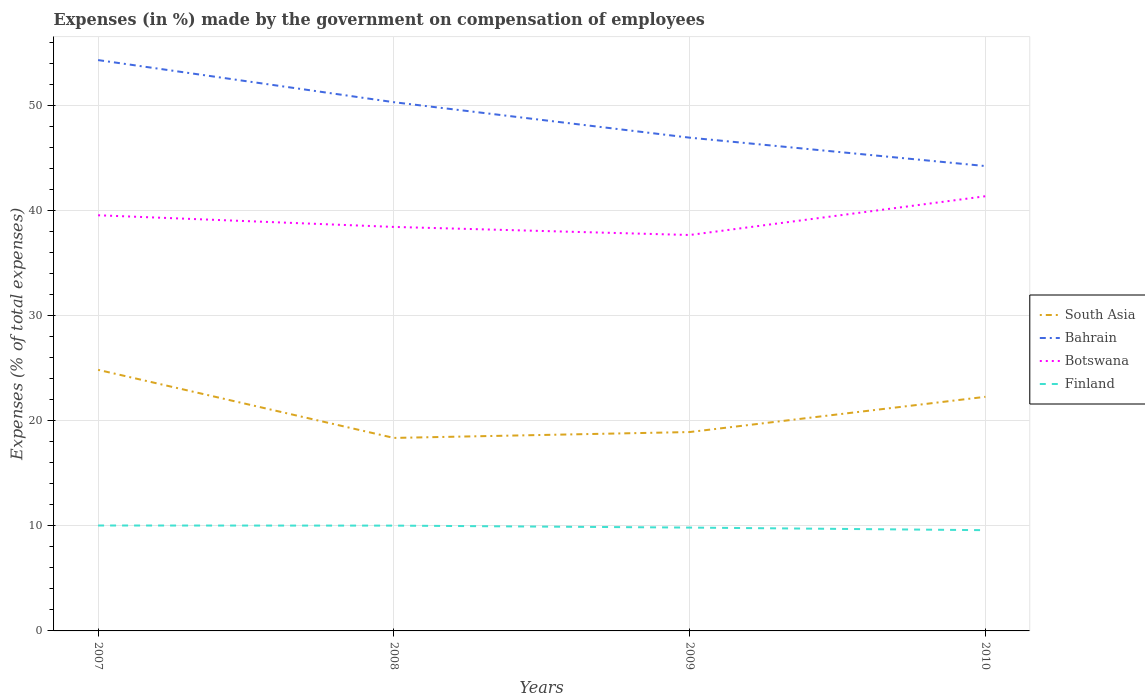How many different coloured lines are there?
Offer a very short reply. 4. Does the line corresponding to Botswana intersect with the line corresponding to South Asia?
Your answer should be compact. No. Is the number of lines equal to the number of legend labels?
Provide a short and direct response. Yes. Across all years, what is the maximum percentage of expenses made by the government on compensation of employees in Finland?
Provide a succinct answer. 9.58. What is the total percentage of expenses made by the government on compensation of employees in Bahrain in the graph?
Give a very brief answer. 6.07. What is the difference between the highest and the second highest percentage of expenses made by the government on compensation of employees in Finland?
Keep it short and to the point. 0.45. What is the difference between the highest and the lowest percentage of expenses made by the government on compensation of employees in South Asia?
Your answer should be compact. 2. How many lines are there?
Offer a very short reply. 4. How many years are there in the graph?
Provide a short and direct response. 4. Are the values on the major ticks of Y-axis written in scientific E-notation?
Provide a succinct answer. No. Does the graph contain any zero values?
Give a very brief answer. No. Does the graph contain grids?
Give a very brief answer. Yes. Where does the legend appear in the graph?
Offer a very short reply. Center right. How many legend labels are there?
Provide a succinct answer. 4. What is the title of the graph?
Provide a short and direct response. Expenses (in %) made by the government on compensation of employees. Does "Tunisia" appear as one of the legend labels in the graph?
Offer a terse response. No. What is the label or title of the Y-axis?
Give a very brief answer. Expenses (% of total expenses). What is the Expenses (% of total expenses) in South Asia in 2007?
Your response must be concise. 24.84. What is the Expenses (% of total expenses) of Bahrain in 2007?
Give a very brief answer. 54.31. What is the Expenses (% of total expenses) in Botswana in 2007?
Offer a very short reply. 39.54. What is the Expenses (% of total expenses) of Finland in 2007?
Give a very brief answer. 10.03. What is the Expenses (% of total expenses) in South Asia in 2008?
Your response must be concise. 18.36. What is the Expenses (% of total expenses) of Bahrain in 2008?
Your response must be concise. 50.3. What is the Expenses (% of total expenses) in Botswana in 2008?
Your response must be concise. 38.43. What is the Expenses (% of total expenses) of Finland in 2008?
Keep it short and to the point. 10.02. What is the Expenses (% of total expenses) of South Asia in 2009?
Your answer should be very brief. 18.92. What is the Expenses (% of total expenses) of Bahrain in 2009?
Keep it short and to the point. 46.93. What is the Expenses (% of total expenses) of Botswana in 2009?
Offer a terse response. 37.66. What is the Expenses (% of total expenses) in Finland in 2009?
Your answer should be compact. 9.83. What is the Expenses (% of total expenses) of South Asia in 2010?
Provide a short and direct response. 22.27. What is the Expenses (% of total expenses) in Bahrain in 2010?
Offer a terse response. 44.22. What is the Expenses (% of total expenses) in Botswana in 2010?
Offer a terse response. 41.35. What is the Expenses (% of total expenses) in Finland in 2010?
Keep it short and to the point. 9.58. Across all years, what is the maximum Expenses (% of total expenses) of South Asia?
Provide a short and direct response. 24.84. Across all years, what is the maximum Expenses (% of total expenses) in Bahrain?
Offer a very short reply. 54.31. Across all years, what is the maximum Expenses (% of total expenses) of Botswana?
Your answer should be compact. 41.35. Across all years, what is the maximum Expenses (% of total expenses) in Finland?
Provide a succinct answer. 10.03. Across all years, what is the minimum Expenses (% of total expenses) of South Asia?
Your answer should be very brief. 18.36. Across all years, what is the minimum Expenses (% of total expenses) in Bahrain?
Make the answer very short. 44.22. Across all years, what is the minimum Expenses (% of total expenses) in Botswana?
Ensure brevity in your answer.  37.66. Across all years, what is the minimum Expenses (% of total expenses) in Finland?
Ensure brevity in your answer.  9.58. What is the total Expenses (% of total expenses) in South Asia in the graph?
Your response must be concise. 84.39. What is the total Expenses (% of total expenses) in Bahrain in the graph?
Offer a very short reply. 195.75. What is the total Expenses (% of total expenses) of Botswana in the graph?
Keep it short and to the point. 156.99. What is the total Expenses (% of total expenses) of Finland in the graph?
Provide a succinct answer. 39.46. What is the difference between the Expenses (% of total expenses) of South Asia in 2007 and that in 2008?
Make the answer very short. 6.48. What is the difference between the Expenses (% of total expenses) in Bahrain in 2007 and that in 2008?
Keep it short and to the point. 4.01. What is the difference between the Expenses (% of total expenses) in Botswana in 2007 and that in 2008?
Offer a terse response. 1.11. What is the difference between the Expenses (% of total expenses) of Finland in 2007 and that in 2008?
Ensure brevity in your answer.  0.01. What is the difference between the Expenses (% of total expenses) in South Asia in 2007 and that in 2009?
Provide a succinct answer. 5.92. What is the difference between the Expenses (% of total expenses) of Bahrain in 2007 and that in 2009?
Provide a succinct answer. 7.38. What is the difference between the Expenses (% of total expenses) of Botswana in 2007 and that in 2009?
Offer a very short reply. 1.88. What is the difference between the Expenses (% of total expenses) of Finland in 2007 and that in 2009?
Offer a very short reply. 0.2. What is the difference between the Expenses (% of total expenses) of South Asia in 2007 and that in 2010?
Your response must be concise. 2.57. What is the difference between the Expenses (% of total expenses) of Bahrain in 2007 and that in 2010?
Provide a short and direct response. 10.08. What is the difference between the Expenses (% of total expenses) in Botswana in 2007 and that in 2010?
Your response must be concise. -1.81. What is the difference between the Expenses (% of total expenses) of Finland in 2007 and that in 2010?
Offer a terse response. 0.45. What is the difference between the Expenses (% of total expenses) of South Asia in 2008 and that in 2009?
Keep it short and to the point. -0.56. What is the difference between the Expenses (% of total expenses) in Bahrain in 2008 and that in 2009?
Offer a terse response. 3.37. What is the difference between the Expenses (% of total expenses) in Botswana in 2008 and that in 2009?
Your answer should be very brief. 0.77. What is the difference between the Expenses (% of total expenses) in Finland in 2008 and that in 2009?
Give a very brief answer. 0.19. What is the difference between the Expenses (% of total expenses) in South Asia in 2008 and that in 2010?
Give a very brief answer. -3.91. What is the difference between the Expenses (% of total expenses) in Bahrain in 2008 and that in 2010?
Provide a succinct answer. 6.08. What is the difference between the Expenses (% of total expenses) in Botswana in 2008 and that in 2010?
Provide a short and direct response. -2.92. What is the difference between the Expenses (% of total expenses) in Finland in 2008 and that in 2010?
Your response must be concise. 0.43. What is the difference between the Expenses (% of total expenses) of South Asia in 2009 and that in 2010?
Offer a terse response. -3.35. What is the difference between the Expenses (% of total expenses) in Bahrain in 2009 and that in 2010?
Keep it short and to the point. 2.7. What is the difference between the Expenses (% of total expenses) in Botswana in 2009 and that in 2010?
Ensure brevity in your answer.  -3.69. What is the difference between the Expenses (% of total expenses) of Finland in 2009 and that in 2010?
Offer a terse response. 0.25. What is the difference between the Expenses (% of total expenses) of South Asia in 2007 and the Expenses (% of total expenses) of Bahrain in 2008?
Provide a succinct answer. -25.46. What is the difference between the Expenses (% of total expenses) in South Asia in 2007 and the Expenses (% of total expenses) in Botswana in 2008?
Offer a terse response. -13.6. What is the difference between the Expenses (% of total expenses) of South Asia in 2007 and the Expenses (% of total expenses) of Finland in 2008?
Your answer should be compact. 14.82. What is the difference between the Expenses (% of total expenses) of Bahrain in 2007 and the Expenses (% of total expenses) of Botswana in 2008?
Your answer should be very brief. 15.87. What is the difference between the Expenses (% of total expenses) in Bahrain in 2007 and the Expenses (% of total expenses) in Finland in 2008?
Offer a very short reply. 44.29. What is the difference between the Expenses (% of total expenses) of Botswana in 2007 and the Expenses (% of total expenses) of Finland in 2008?
Your answer should be compact. 29.52. What is the difference between the Expenses (% of total expenses) in South Asia in 2007 and the Expenses (% of total expenses) in Bahrain in 2009?
Offer a terse response. -22.09. What is the difference between the Expenses (% of total expenses) in South Asia in 2007 and the Expenses (% of total expenses) in Botswana in 2009?
Ensure brevity in your answer.  -12.83. What is the difference between the Expenses (% of total expenses) in South Asia in 2007 and the Expenses (% of total expenses) in Finland in 2009?
Offer a very short reply. 15.01. What is the difference between the Expenses (% of total expenses) in Bahrain in 2007 and the Expenses (% of total expenses) in Botswana in 2009?
Provide a short and direct response. 16.64. What is the difference between the Expenses (% of total expenses) of Bahrain in 2007 and the Expenses (% of total expenses) of Finland in 2009?
Your answer should be compact. 44.47. What is the difference between the Expenses (% of total expenses) of Botswana in 2007 and the Expenses (% of total expenses) of Finland in 2009?
Provide a succinct answer. 29.71. What is the difference between the Expenses (% of total expenses) in South Asia in 2007 and the Expenses (% of total expenses) in Bahrain in 2010?
Ensure brevity in your answer.  -19.39. What is the difference between the Expenses (% of total expenses) of South Asia in 2007 and the Expenses (% of total expenses) of Botswana in 2010?
Make the answer very short. -16.51. What is the difference between the Expenses (% of total expenses) of South Asia in 2007 and the Expenses (% of total expenses) of Finland in 2010?
Ensure brevity in your answer.  15.25. What is the difference between the Expenses (% of total expenses) in Bahrain in 2007 and the Expenses (% of total expenses) in Botswana in 2010?
Offer a terse response. 12.95. What is the difference between the Expenses (% of total expenses) of Bahrain in 2007 and the Expenses (% of total expenses) of Finland in 2010?
Provide a succinct answer. 44.72. What is the difference between the Expenses (% of total expenses) of Botswana in 2007 and the Expenses (% of total expenses) of Finland in 2010?
Provide a short and direct response. 29.96. What is the difference between the Expenses (% of total expenses) of South Asia in 2008 and the Expenses (% of total expenses) of Bahrain in 2009?
Offer a terse response. -28.56. What is the difference between the Expenses (% of total expenses) of South Asia in 2008 and the Expenses (% of total expenses) of Botswana in 2009?
Give a very brief answer. -19.3. What is the difference between the Expenses (% of total expenses) of South Asia in 2008 and the Expenses (% of total expenses) of Finland in 2009?
Your answer should be very brief. 8.53. What is the difference between the Expenses (% of total expenses) in Bahrain in 2008 and the Expenses (% of total expenses) in Botswana in 2009?
Provide a short and direct response. 12.63. What is the difference between the Expenses (% of total expenses) of Bahrain in 2008 and the Expenses (% of total expenses) of Finland in 2009?
Provide a succinct answer. 40.47. What is the difference between the Expenses (% of total expenses) in Botswana in 2008 and the Expenses (% of total expenses) in Finland in 2009?
Make the answer very short. 28.6. What is the difference between the Expenses (% of total expenses) of South Asia in 2008 and the Expenses (% of total expenses) of Bahrain in 2010?
Offer a terse response. -25.86. What is the difference between the Expenses (% of total expenses) in South Asia in 2008 and the Expenses (% of total expenses) in Botswana in 2010?
Give a very brief answer. -22.99. What is the difference between the Expenses (% of total expenses) in South Asia in 2008 and the Expenses (% of total expenses) in Finland in 2010?
Your answer should be compact. 8.78. What is the difference between the Expenses (% of total expenses) of Bahrain in 2008 and the Expenses (% of total expenses) of Botswana in 2010?
Make the answer very short. 8.95. What is the difference between the Expenses (% of total expenses) of Bahrain in 2008 and the Expenses (% of total expenses) of Finland in 2010?
Keep it short and to the point. 40.72. What is the difference between the Expenses (% of total expenses) in Botswana in 2008 and the Expenses (% of total expenses) in Finland in 2010?
Your answer should be compact. 28.85. What is the difference between the Expenses (% of total expenses) of South Asia in 2009 and the Expenses (% of total expenses) of Bahrain in 2010?
Provide a short and direct response. -25.3. What is the difference between the Expenses (% of total expenses) in South Asia in 2009 and the Expenses (% of total expenses) in Botswana in 2010?
Offer a very short reply. -22.43. What is the difference between the Expenses (% of total expenses) in South Asia in 2009 and the Expenses (% of total expenses) in Finland in 2010?
Keep it short and to the point. 9.34. What is the difference between the Expenses (% of total expenses) in Bahrain in 2009 and the Expenses (% of total expenses) in Botswana in 2010?
Provide a succinct answer. 5.57. What is the difference between the Expenses (% of total expenses) in Bahrain in 2009 and the Expenses (% of total expenses) in Finland in 2010?
Make the answer very short. 37.34. What is the difference between the Expenses (% of total expenses) of Botswana in 2009 and the Expenses (% of total expenses) of Finland in 2010?
Make the answer very short. 28.08. What is the average Expenses (% of total expenses) in South Asia per year?
Your answer should be compact. 21.1. What is the average Expenses (% of total expenses) of Bahrain per year?
Your answer should be compact. 48.94. What is the average Expenses (% of total expenses) in Botswana per year?
Keep it short and to the point. 39.25. What is the average Expenses (% of total expenses) in Finland per year?
Make the answer very short. 9.87. In the year 2007, what is the difference between the Expenses (% of total expenses) in South Asia and Expenses (% of total expenses) in Bahrain?
Ensure brevity in your answer.  -29.47. In the year 2007, what is the difference between the Expenses (% of total expenses) in South Asia and Expenses (% of total expenses) in Botswana?
Your answer should be very brief. -14.7. In the year 2007, what is the difference between the Expenses (% of total expenses) of South Asia and Expenses (% of total expenses) of Finland?
Your answer should be very brief. 14.81. In the year 2007, what is the difference between the Expenses (% of total expenses) in Bahrain and Expenses (% of total expenses) in Botswana?
Your response must be concise. 14.76. In the year 2007, what is the difference between the Expenses (% of total expenses) in Bahrain and Expenses (% of total expenses) in Finland?
Offer a terse response. 44.28. In the year 2007, what is the difference between the Expenses (% of total expenses) of Botswana and Expenses (% of total expenses) of Finland?
Provide a short and direct response. 29.51. In the year 2008, what is the difference between the Expenses (% of total expenses) in South Asia and Expenses (% of total expenses) in Bahrain?
Your response must be concise. -31.94. In the year 2008, what is the difference between the Expenses (% of total expenses) in South Asia and Expenses (% of total expenses) in Botswana?
Ensure brevity in your answer.  -20.07. In the year 2008, what is the difference between the Expenses (% of total expenses) of South Asia and Expenses (% of total expenses) of Finland?
Give a very brief answer. 8.34. In the year 2008, what is the difference between the Expenses (% of total expenses) of Bahrain and Expenses (% of total expenses) of Botswana?
Make the answer very short. 11.87. In the year 2008, what is the difference between the Expenses (% of total expenses) of Bahrain and Expenses (% of total expenses) of Finland?
Your response must be concise. 40.28. In the year 2008, what is the difference between the Expenses (% of total expenses) of Botswana and Expenses (% of total expenses) of Finland?
Your answer should be very brief. 28.42. In the year 2009, what is the difference between the Expenses (% of total expenses) in South Asia and Expenses (% of total expenses) in Bahrain?
Offer a terse response. -28.01. In the year 2009, what is the difference between the Expenses (% of total expenses) in South Asia and Expenses (% of total expenses) in Botswana?
Give a very brief answer. -18.75. In the year 2009, what is the difference between the Expenses (% of total expenses) in South Asia and Expenses (% of total expenses) in Finland?
Provide a succinct answer. 9.09. In the year 2009, what is the difference between the Expenses (% of total expenses) in Bahrain and Expenses (% of total expenses) in Botswana?
Provide a succinct answer. 9.26. In the year 2009, what is the difference between the Expenses (% of total expenses) of Bahrain and Expenses (% of total expenses) of Finland?
Your response must be concise. 37.09. In the year 2009, what is the difference between the Expenses (% of total expenses) of Botswana and Expenses (% of total expenses) of Finland?
Your answer should be very brief. 27.83. In the year 2010, what is the difference between the Expenses (% of total expenses) in South Asia and Expenses (% of total expenses) in Bahrain?
Provide a succinct answer. -21.95. In the year 2010, what is the difference between the Expenses (% of total expenses) in South Asia and Expenses (% of total expenses) in Botswana?
Your response must be concise. -19.08. In the year 2010, what is the difference between the Expenses (% of total expenses) in South Asia and Expenses (% of total expenses) in Finland?
Offer a terse response. 12.69. In the year 2010, what is the difference between the Expenses (% of total expenses) in Bahrain and Expenses (% of total expenses) in Botswana?
Keep it short and to the point. 2.87. In the year 2010, what is the difference between the Expenses (% of total expenses) of Bahrain and Expenses (% of total expenses) of Finland?
Your response must be concise. 34.64. In the year 2010, what is the difference between the Expenses (% of total expenses) in Botswana and Expenses (% of total expenses) in Finland?
Offer a terse response. 31.77. What is the ratio of the Expenses (% of total expenses) in South Asia in 2007 to that in 2008?
Offer a very short reply. 1.35. What is the ratio of the Expenses (% of total expenses) in Bahrain in 2007 to that in 2008?
Give a very brief answer. 1.08. What is the ratio of the Expenses (% of total expenses) of Botswana in 2007 to that in 2008?
Your answer should be compact. 1.03. What is the ratio of the Expenses (% of total expenses) of Finland in 2007 to that in 2008?
Keep it short and to the point. 1. What is the ratio of the Expenses (% of total expenses) in South Asia in 2007 to that in 2009?
Provide a succinct answer. 1.31. What is the ratio of the Expenses (% of total expenses) of Bahrain in 2007 to that in 2009?
Provide a short and direct response. 1.16. What is the ratio of the Expenses (% of total expenses) of Botswana in 2007 to that in 2009?
Provide a short and direct response. 1.05. What is the ratio of the Expenses (% of total expenses) in Finland in 2007 to that in 2009?
Your answer should be compact. 1.02. What is the ratio of the Expenses (% of total expenses) of South Asia in 2007 to that in 2010?
Give a very brief answer. 1.12. What is the ratio of the Expenses (% of total expenses) in Bahrain in 2007 to that in 2010?
Ensure brevity in your answer.  1.23. What is the ratio of the Expenses (% of total expenses) in Botswana in 2007 to that in 2010?
Give a very brief answer. 0.96. What is the ratio of the Expenses (% of total expenses) in Finland in 2007 to that in 2010?
Your response must be concise. 1.05. What is the ratio of the Expenses (% of total expenses) in South Asia in 2008 to that in 2009?
Offer a very short reply. 0.97. What is the ratio of the Expenses (% of total expenses) of Bahrain in 2008 to that in 2009?
Offer a terse response. 1.07. What is the ratio of the Expenses (% of total expenses) of Botswana in 2008 to that in 2009?
Offer a very short reply. 1.02. What is the ratio of the Expenses (% of total expenses) of Finland in 2008 to that in 2009?
Your response must be concise. 1.02. What is the ratio of the Expenses (% of total expenses) of South Asia in 2008 to that in 2010?
Offer a very short reply. 0.82. What is the ratio of the Expenses (% of total expenses) in Bahrain in 2008 to that in 2010?
Offer a very short reply. 1.14. What is the ratio of the Expenses (% of total expenses) in Botswana in 2008 to that in 2010?
Your response must be concise. 0.93. What is the ratio of the Expenses (% of total expenses) of Finland in 2008 to that in 2010?
Offer a terse response. 1.05. What is the ratio of the Expenses (% of total expenses) of South Asia in 2009 to that in 2010?
Your answer should be very brief. 0.85. What is the ratio of the Expenses (% of total expenses) of Bahrain in 2009 to that in 2010?
Offer a very short reply. 1.06. What is the ratio of the Expenses (% of total expenses) in Botswana in 2009 to that in 2010?
Provide a succinct answer. 0.91. What is the ratio of the Expenses (% of total expenses) of Finland in 2009 to that in 2010?
Give a very brief answer. 1.03. What is the difference between the highest and the second highest Expenses (% of total expenses) of South Asia?
Your answer should be very brief. 2.57. What is the difference between the highest and the second highest Expenses (% of total expenses) in Bahrain?
Provide a succinct answer. 4.01. What is the difference between the highest and the second highest Expenses (% of total expenses) of Botswana?
Provide a short and direct response. 1.81. What is the difference between the highest and the second highest Expenses (% of total expenses) in Finland?
Your answer should be compact. 0.01. What is the difference between the highest and the lowest Expenses (% of total expenses) in South Asia?
Offer a very short reply. 6.48. What is the difference between the highest and the lowest Expenses (% of total expenses) in Bahrain?
Offer a very short reply. 10.08. What is the difference between the highest and the lowest Expenses (% of total expenses) of Botswana?
Make the answer very short. 3.69. What is the difference between the highest and the lowest Expenses (% of total expenses) in Finland?
Offer a terse response. 0.45. 